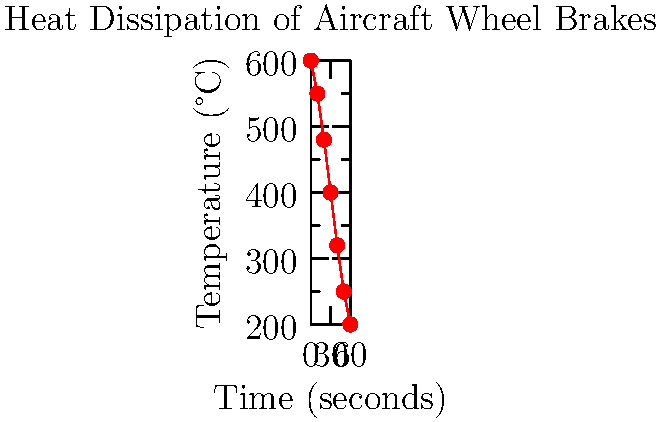As a ground handler, you're observing the cooling process of aircraft wheel brakes after landing. The graph shows the temperature decrease over time. What is the average rate of temperature decrease in °C/s during the first 30 seconds after landing? To find the average rate of temperature decrease, we need to follow these steps:

1. Identify the initial temperature (at t = 0s):
   Initial temperature = 600°C

2. Identify the temperature after 30 seconds:
   Temperature at t = 30s = 400°C

3. Calculate the total temperature decrease:
   Temperature decrease = Initial temperature - Temperature at 30s
   Temperature decrease = 600°C - 400°C = 200°C

4. Calculate the time interval:
   Time interval = 30 seconds

5. Calculate the average rate of temperature decrease:
   Average rate = Total temperature decrease ÷ Time interval
   Average rate = 200°C ÷ 30s = 6.67°C/s

Therefore, the average rate of temperature decrease during the first 30 seconds after landing is approximately 6.67°C/s.
Answer: 6.67°C/s 